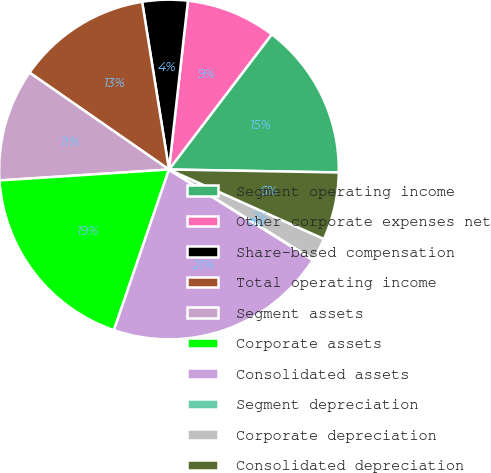<chart> <loc_0><loc_0><loc_500><loc_500><pie_chart><fcel>Segment operating income<fcel>Other corporate expenses net<fcel>Share-based compensation<fcel>Total operating income<fcel>Segment assets<fcel>Corporate assets<fcel>Consolidated assets<fcel>Segment depreciation<fcel>Corporate depreciation<fcel>Consolidated depreciation<nl><fcel>14.94%<fcel>8.56%<fcel>4.31%<fcel>12.81%<fcel>10.69%<fcel>18.72%<fcel>21.32%<fcel>0.05%<fcel>2.18%<fcel>6.43%<nl></chart> 